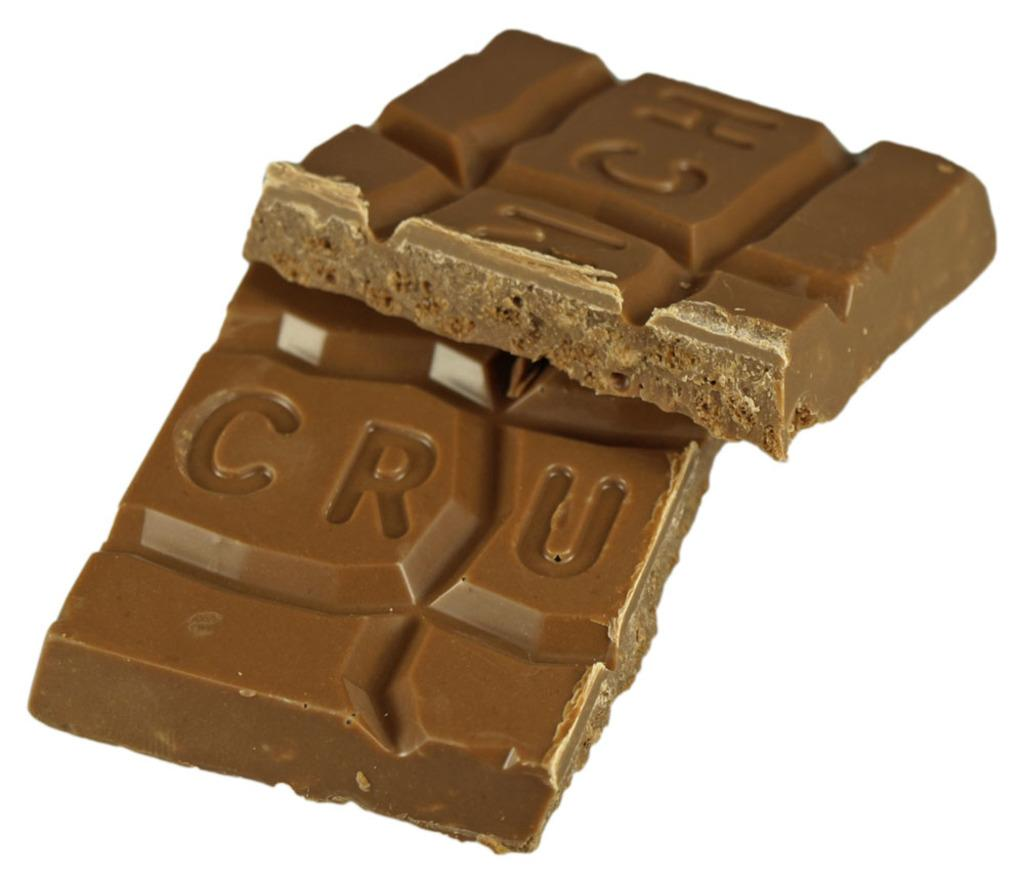What is the main subject of the image? The main subject of the image is a chocolate. Can you describe the surface on which the chocolate is placed? The chocolate is placed on a white surface. What type of owl can be seen in the image? There is no owl present in the image; it features a chocolate on a white surface. What kind of scene is depicted in the image? The image does not depict a scene; it is a close-up of a chocolate on a white surface. 